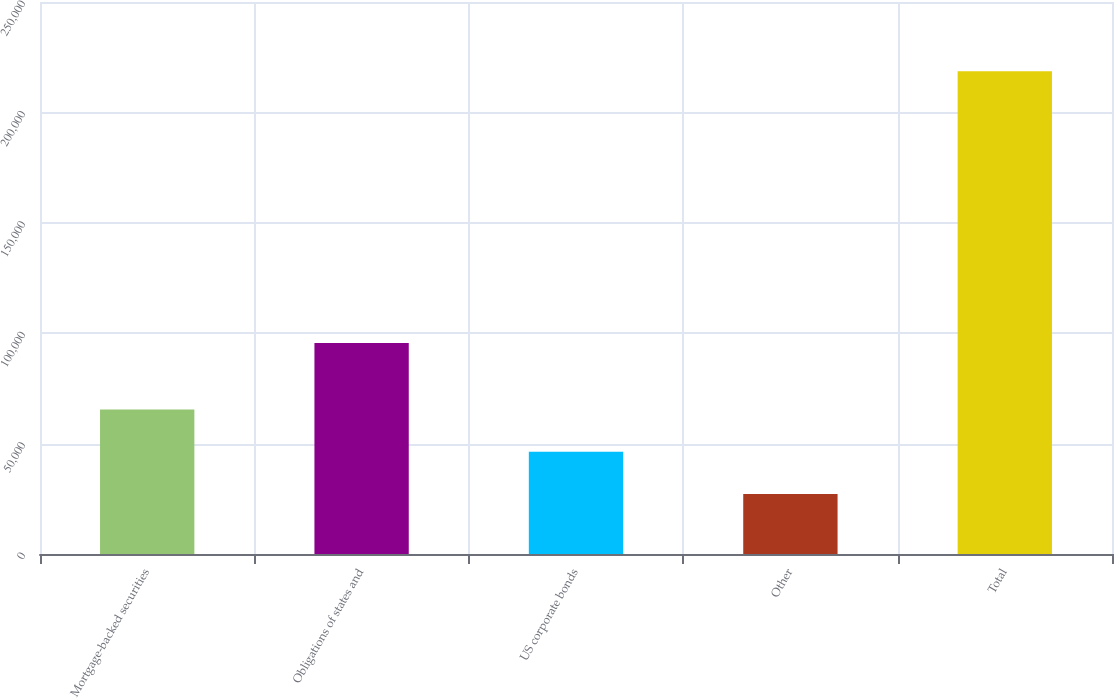Convert chart. <chart><loc_0><loc_0><loc_500><loc_500><bar_chart><fcel>Mortgage-backed securities<fcel>Obligations of states and<fcel>US corporate bonds<fcel>Other<fcel>Total<nl><fcel>65497.8<fcel>95544<fcel>46348.9<fcel>27200<fcel>218689<nl></chart> 